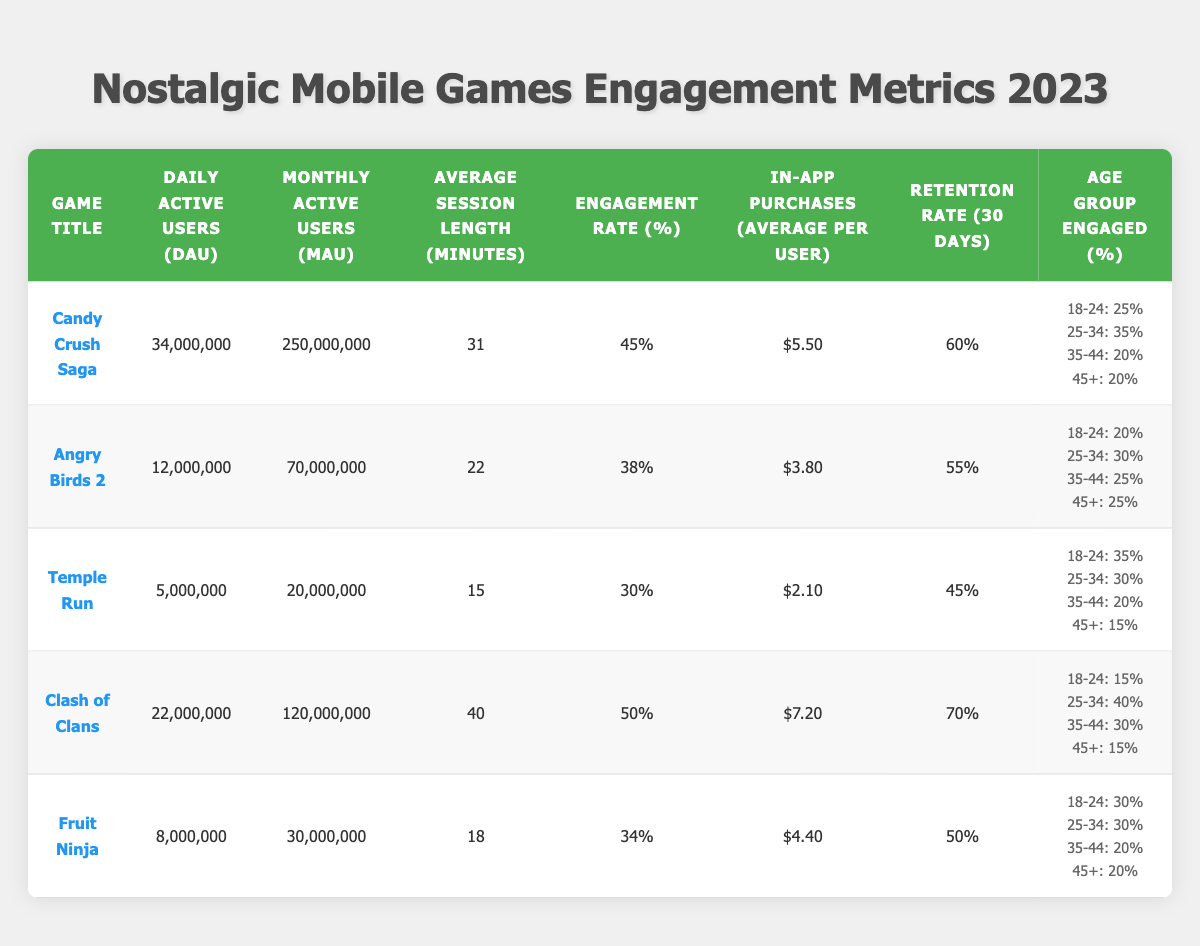What is the game with the highest Daily Active Users? Looking at the table, "Candy Crush Saga" has the highest Daily Active Users with 34,000,000.
Answer: Candy Crush Saga What percentage of players aged 25-34 engage with "Clash of Clans"? From the table, 40% of players aged 25-34 are engaged with "Clash of Clans".
Answer: 40% Which game has the longest average session length? "Clash of Clans" has the longest average session length at 40 minutes.
Answer: Clash of Clans Is the Retention Rate of "Angry Birds 2" higher than that of "Temple Run"? "Angry Birds 2" has a Retention Rate of 55%, while "Temple Run" has 45%. Therefore, yes, "Angry Birds 2" has a higher Retention Rate.
Answer: Yes What is the average In-App Purchases per User across all games listed? Calculate the average: (5.5 + 3.8 + 2.1 + 7.2 + 4.4) / 5 = 4.2. The average In-App Purchases per User is $4.2.
Answer: 4.2 Which game has the lowest Engagement Rate? Reviewing the table, "Temple Run" has the lowest Engagement Rate at 30%.
Answer: Temple Run How many total Daily Active Users are there across all games? Add the Daily Active Users: 34,000,000 + 12,000,000 + 5,000,000 + 22,000,000 + 8,000,000 = 81,000,000.
Answer: 81,000,000 Does "Fruit Ninja" have a higher Engagement Rate than "Angry Birds 2"? "Fruit Ninja" has an Engagement Rate of 34% while "Angry Birds 2" has 38%. So, no, "Fruit Ninja" does not have a higher Engagement Rate.
Answer: No What is the Retention Rate difference between "Candy Crush Saga" and "Clash of Clans"? The difference is 70% (Clash of Clans) - 60% (Candy Crush Saga) = 10%. The Retention Rate difference is 10%.
Answer: 10% Which age group has the most significant engagement in "Temple Run"? The age group 18-24 has the most significant engagement at 35%.
Answer: 18-24 What is the total Monthly Active Users for "Fruit Ninja" and "Temple Run"? Adding the Monthly Active Users: 30,000,000 (Fruit Ninja) + 20,000,000 (Temple Run) = 50,000,000.
Answer: 50,000,000 Which game has a higher average session length, and by how many minutes? "Clash of Clans" has 40 minutes, and "Candy Crush Saga" has 31 minutes. The difference is 40 - 31 = 9 minutes. So, "Clash of Clans" has a higher average session length by 9 minutes.
Answer: 9 minutes What percentage of users for "Angry Birds 2" are between the ages of 35-44? According to the table, 25% of users for "Angry Birds 2" are between the ages of 35-44.
Answer: 25% Which two games have the same age group percentage for 45+ users? Both "Candy Crush Saga" and "Clash of Clans" have 20% of users from the age group 45+.
Answer: Candy Crush Saga and Clash of Clans 